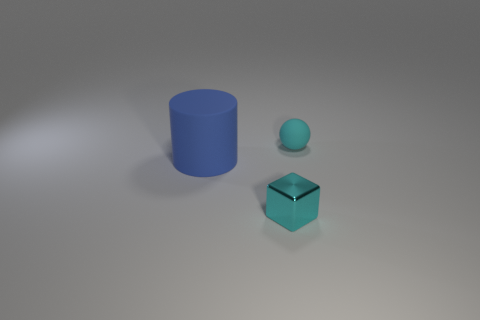What mood or aesthetic does the arrangement of these objects convey? The arrangement of the objects along with the soft lighting conveys a minimalist and serene aesthetic, emphasizing simplicity and order. The cool color palette of blues and the spacing between the items create a calming and composed scene. 